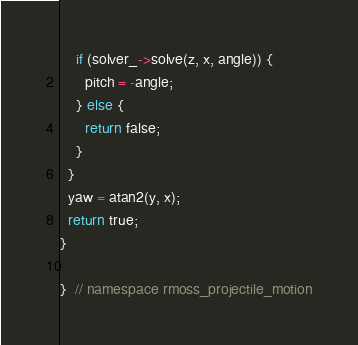Convert code to text. <code><loc_0><loc_0><loc_500><loc_500><_C++_>    if (solver_->solve(z, x, angle)) {
      pitch = -angle;
    } else {
      return false;
    }
  }
  yaw = atan2(y, x);
  return true;
}

}  // namespace rmoss_projectile_motion
</code> 